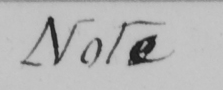Please provide the text content of this handwritten line. Note 